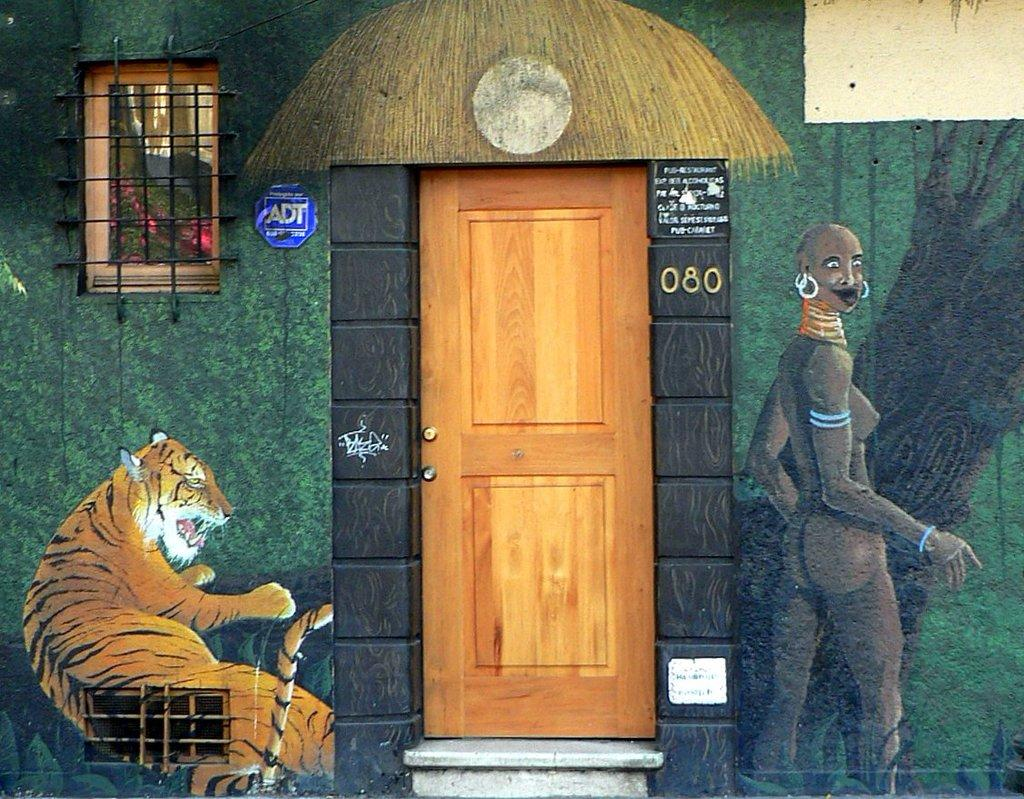What type of architectural feature can be seen in the image? There is a door in the image. What other feature is present in the image that allows light and air to enter? There is a window in the image. What is depicted on the wall in the image? There is a painting of a woman and a tiger on the wall. What can be seen through the window in the image? Leaves are visible through the window. How many stories can be heard being told in the image? There are no stories being told in the image; it only contains a door, window, painting, and leaves visible through the window. 